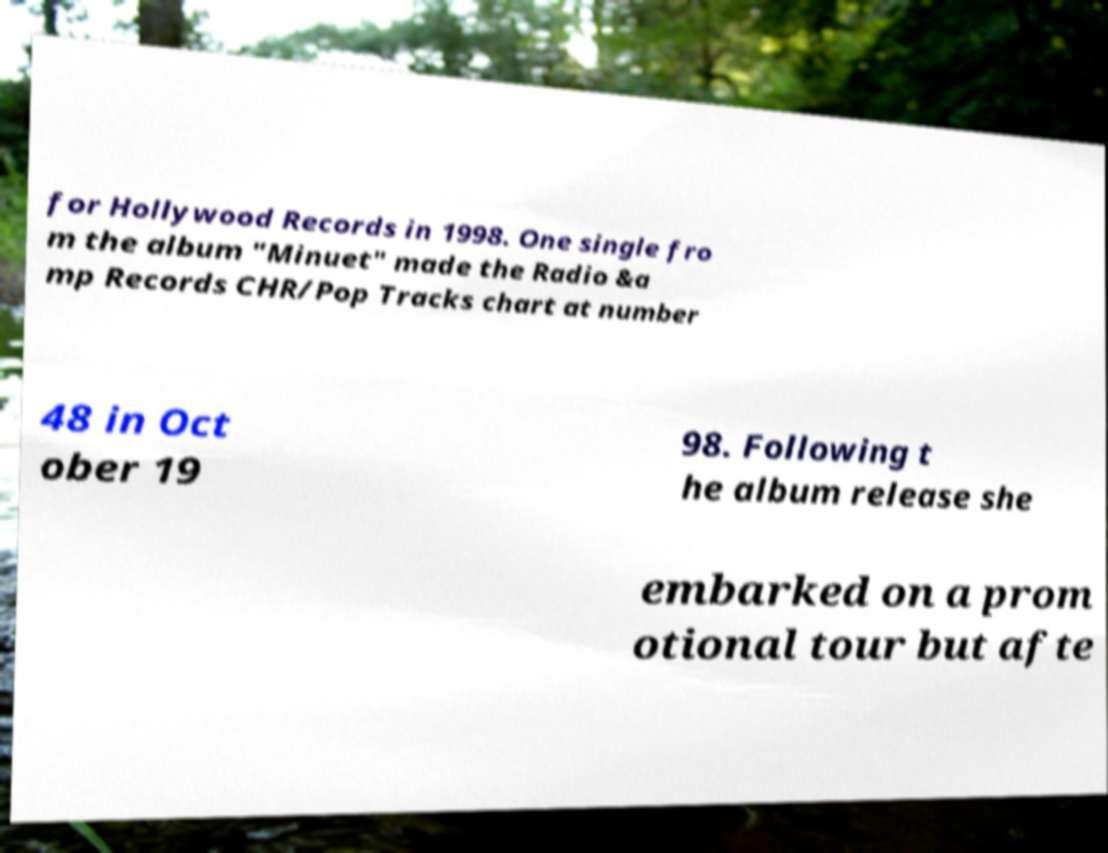What messages or text are displayed in this image? I need them in a readable, typed format. for Hollywood Records in 1998. One single fro m the album "Minuet" made the Radio &a mp Records CHR/Pop Tracks chart at number 48 in Oct ober 19 98. Following t he album release she embarked on a prom otional tour but afte 